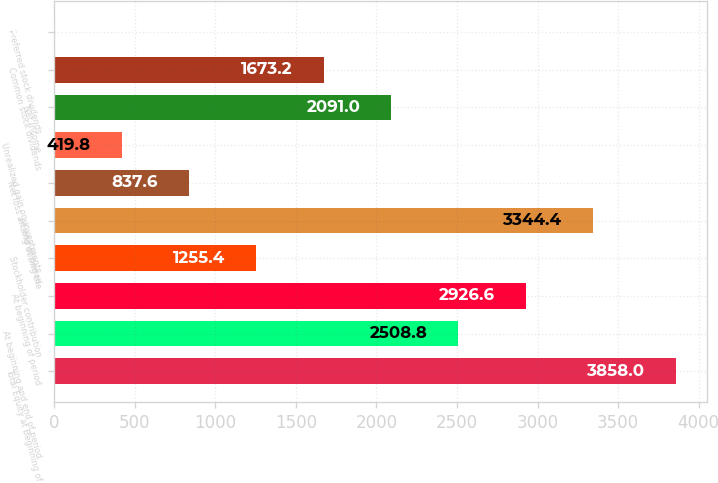Convert chart. <chart><loc_0><loc_0><loc_500><loc_500><bar_chart><fcel>Total Equity at Beginning of<fcel>At beginning and end of period<fcel>At beginning of period<fcel>Stockholder contribution<fcel>At end of period<fcel>Net loss arising during the<fcel>Unrealized gain on investments<fcel>Net income<fcel>Common stock dividends<fcel>Preferred stock dividends<nl><fcel>3858<fcel>2508.8<fcel>2926.6<fcel>1255.4<fcel>3344.4<fcel>837.6<fcel>419.8<fcel>2091<fcel>1673.2<fcel>2<nl></chart> 